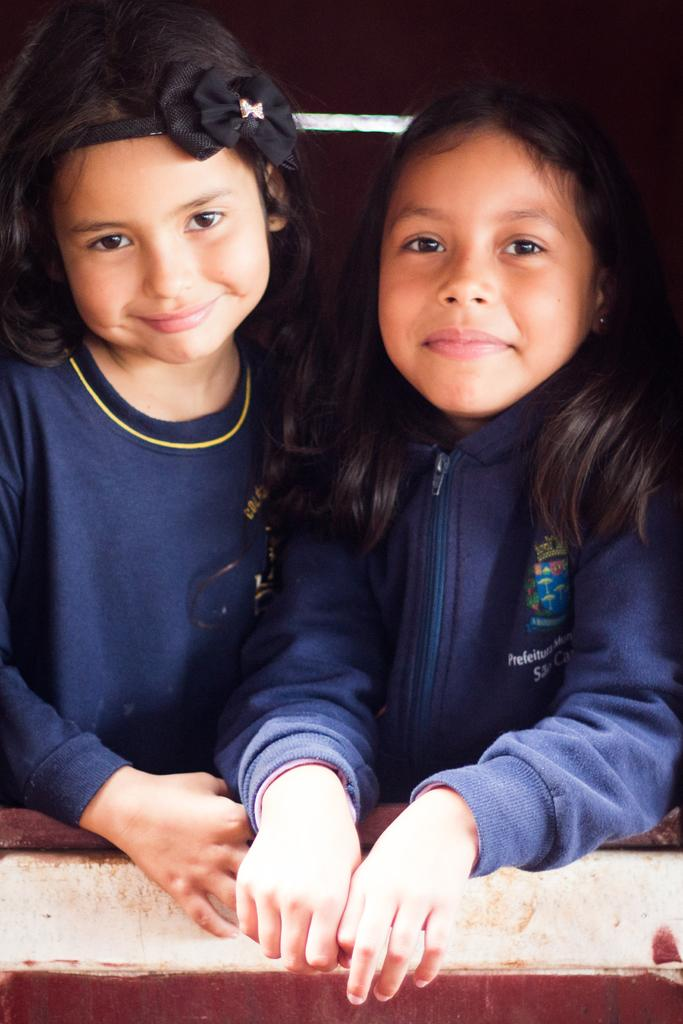Where was the image taken? The image was taken indoors. What can be seen at the bottom of the image? There is a wall at the bottom of the image. What is the main subject of the image? The main subject of the image is two girls. How are the girls feeling in the image? The girls have smiling faces, indicating they are happy or enjoying themselves. What type of loaf is being prepared by the girls in the image? There is no loaf or any indication of food preparation in the image; it features two girls with smiling faces. What color is the mint used by the girls in the image? There is no mint or any reference to herbs in the image; it focuses on the girls and their expressions. 